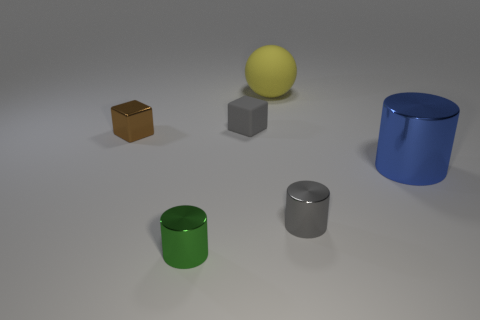There is a big cylinder; is it the same color as the small cube that is on the left side of the small green metallic object?
Ensure brevity in your answer.  No. What is the shape of the tiny brown object?
Give a very brief answer. Cube. Does the tiny matte block have the same color as the large metallic object?
Give a very brief answer. No. What number of objects are either metal things behind the large metallic object or small brown objects?
Offer a terse response. 1. There is a gray cylinder that is made of the same material as the large blue cylinder; what is its size?
Your response must be concise. Small. Are there more yellow spheres to the left of the small matte cube than large metal things?
Keep it short and to the point. No. Do the brown metallic object and the gray thing that is left of the yellow thing have the same shape?
Your answer should be very brief. Yes. What number of small objects are either blue matte cylinders or yellow objects?
Keep it short and to the point. 0. There is a cylinder that is the same color as the small rubber thing; what is its size?
Offer a very short reply. Small. The cylinder behind the small shiny cylinder that is behind the tiny green shiny thing is what color?
Give a very brief answer. Blue. 